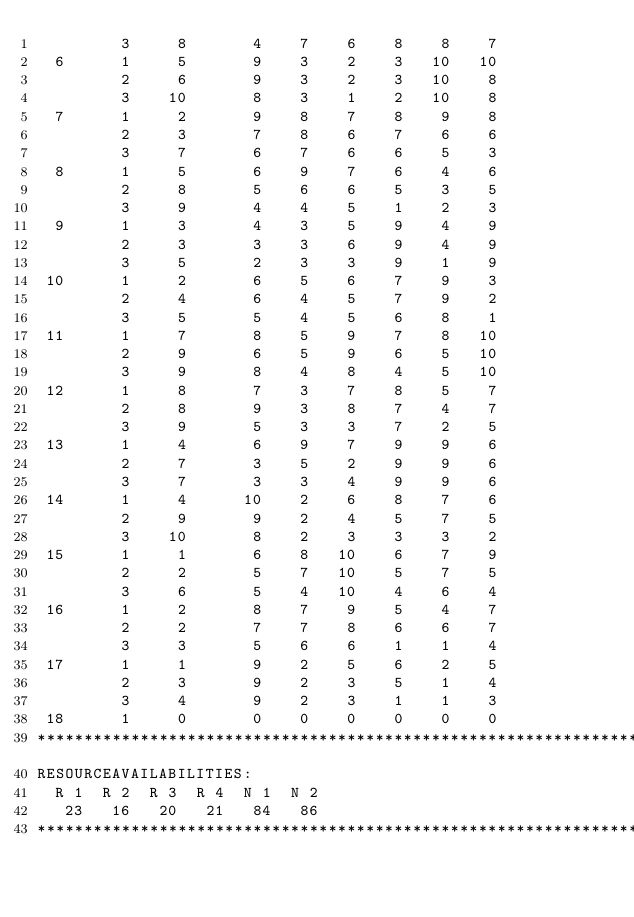Convert code to text. <code><loc_0><loc_0><loc_500><loc_500><_ObjectiveC_>         3     8       4    7    6    8    8    7
  6      1     5       9    3    2    3   10   10
         2     6       9    3    2    3   10    8
         3    10       8    3    1    2   10    8
  7      1     2       9    8    7    8    9    8
         2     3       7    8    6    7    6    6
         3     7       6    7    6    6    5    3
  8      1     5       6    9    7    6    4    6
         2     8       5    6    6    5    3    5
         3     9       4    4    5    1    2    3
  9      1     3       4    3    5    9    4    9
         2     3       3    3    6    9    4    9
         3     5       2    3    3    9    1    9
 10      1     2       6    5    6    7    9    3
         2     4       6    4    5    7    9    2
         3     5       5    4    5    6    8    1
 11      1     7       8    5    9    7    8   10
         2     9       6    5    9    6    5   10
         3     9       8    4    8    4    5   10
 12      1     8       7    3    7    8    5    7
         2     8       9    3    8    7    4    7
         3     9       5    3    3    7    2    5
 13      1     4       6    9    7    9    9    6
         2     7       3    5    2    9    9    6
         3     7       3    3    4    9    9    6
 14      1     4      10    2    6    8    7    6
         2     9       9    2    4    5    7    5
         3    10       8    2    3    3    3    2
 15      1     1       6    8   10    6    7    9
         2     2       5    7   10    5    7    5
         3     6       5    4   10    4    6    4
 16      1     2       8    7    9    5    4    7
         2     2       7    7    8    6    6    7
         3     3       5    6    6    1    1    4
 17      1     1       9    2    5    6    2    5
         2     3       9    2    3    5    1    4
         3     4       9    2    3    1    1    3
 18      1     0       0    0    0    0    0    0
************************************************************************
RESOURCEAVAILABILITIES:
  R 1  R 2  R 3  R 4  N 1  N 2
   23   16   20   21   84   86
************************************************************************
</code> 